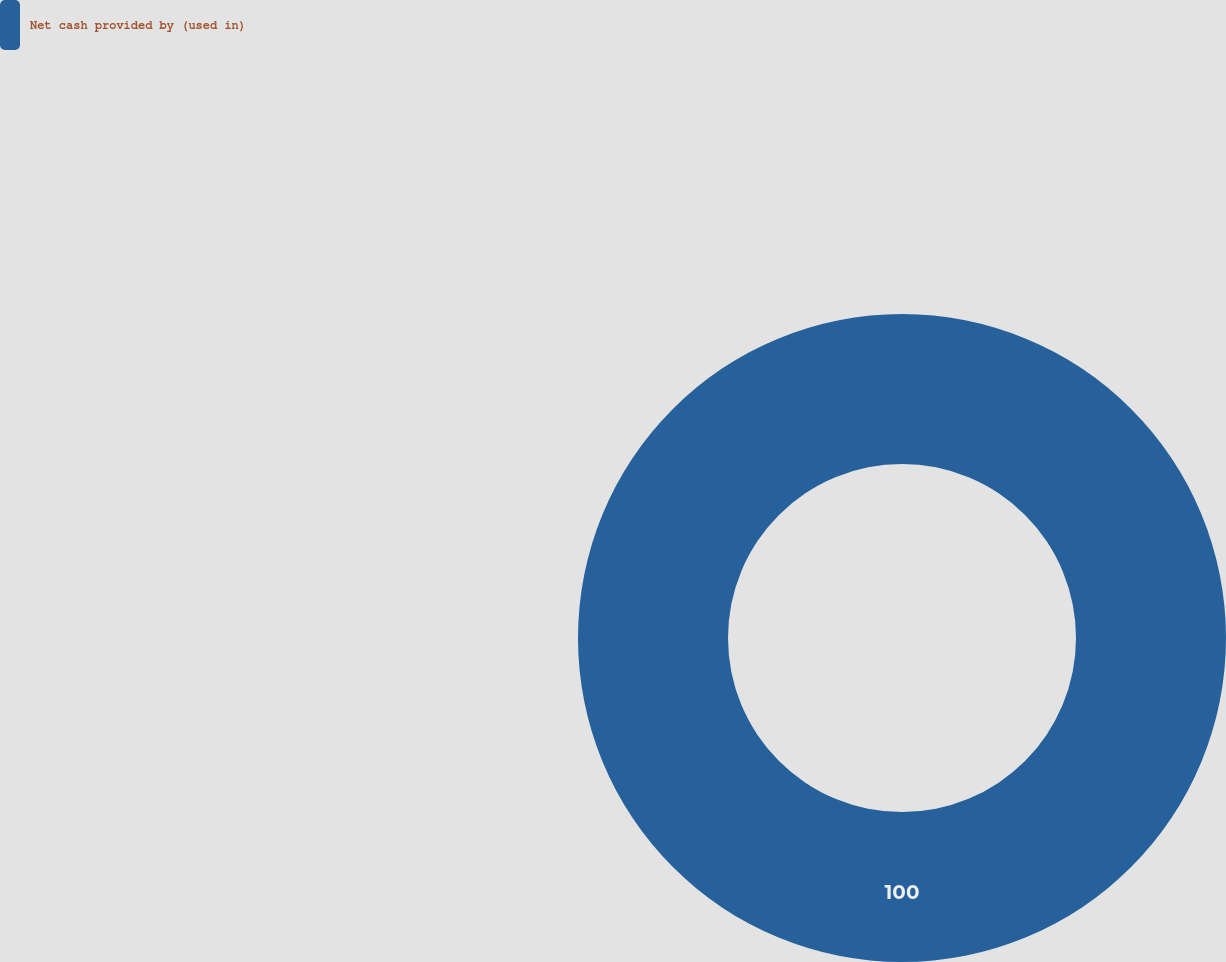Convert chart to OTSL. <chart><loc_0><loc_0><loc_500><loc_500><pie_chart><fcel>Net cash provided by (used in)<nl><fcel>100.0%<nl></chart> 